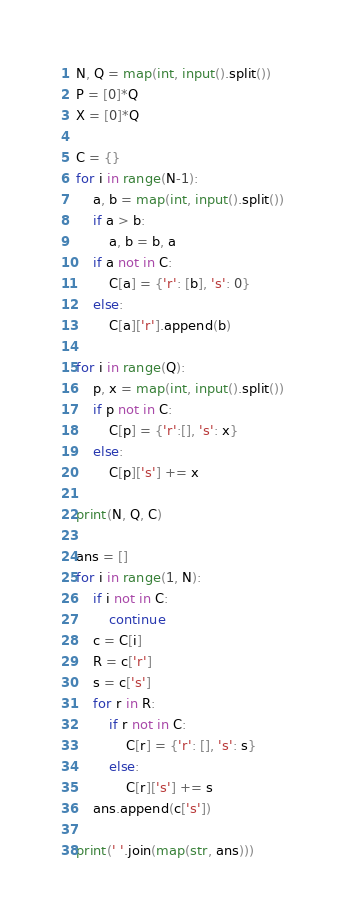Convert code to text. <code><loc_0><loc_0><loc_500><loc_500><_Python_>N, Q = map(int, input().split())
P = [0]*Q
X = [0]*Q

C = {}
for i in range(N-1):
    a, b = map(int, input().split())
    if a > b:
        a, b = b, a
    if a not in C:
        C[a] = {'r': [b], 's': 0}
    else:
        C[a]['r'].append(b)

for i in range(Q):
    p, x = map(int, input().split())
    if p not in C:
        C[p] = {'r':[], 's': x}
    else:
        C[p]['s'] += x

print(N, Q, C)

ans = []
for i in range(1, N):
    if i not in C:
        continue
    c = C[i]
    R = c['r']
    s = c['s']
    for r in R:
        if r not in C:
            C[r] = {'r': [], 's': s}
        else:
            C[r]['s'] += s
    ans.append(c['s'])

print(' '.join(map(str, ans)))
</code> 